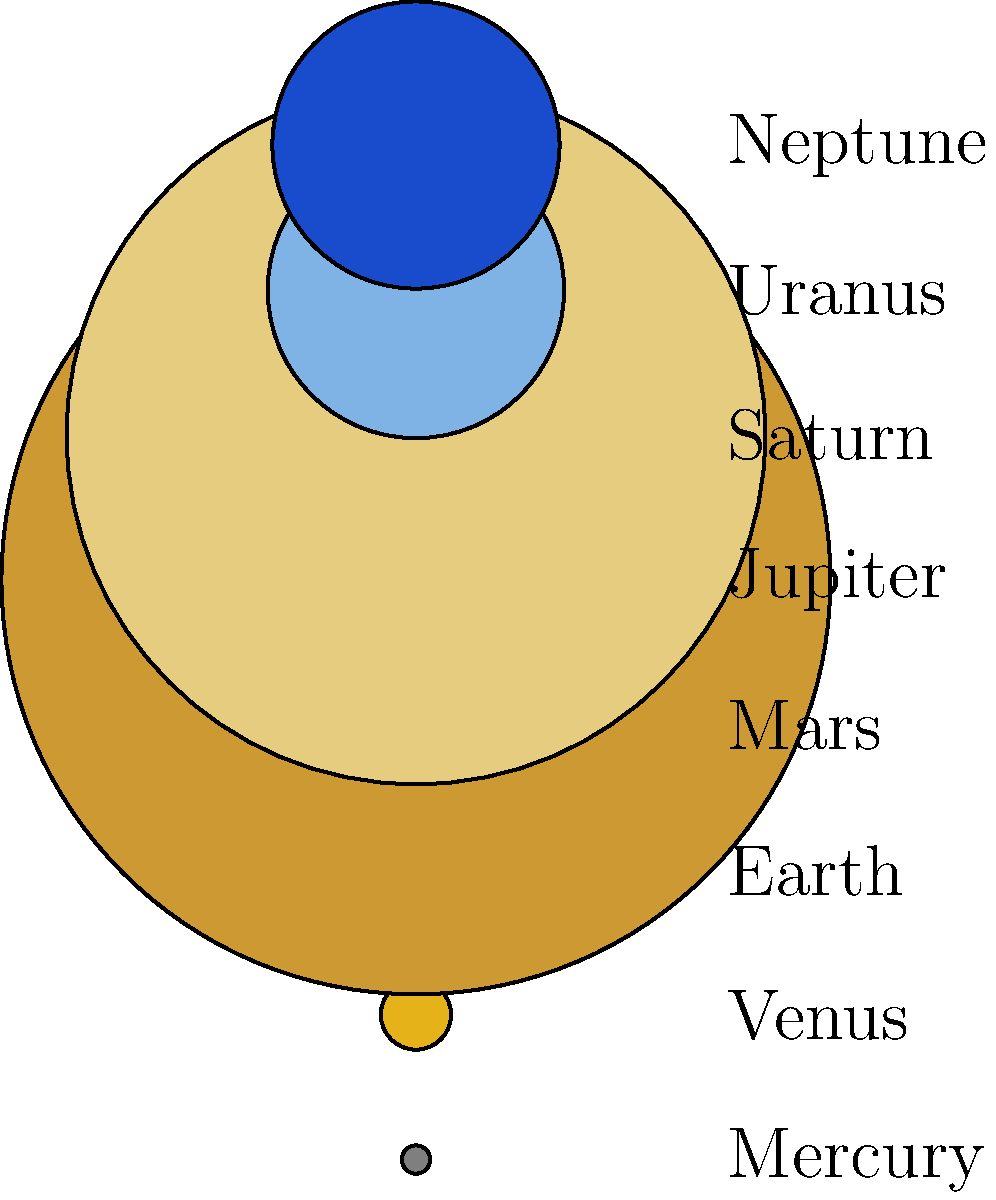In the cosmic jazz ensemble of our solar system, which planet plays the role of the "big bass" with the largest diameter, dwarfing even the smooth rhythm of Earth's blues? To answer this question, let's break down the information presented in the diagram and relate it to our solar system:

1. The diagram shows the relative sizes of the eight planets in our solar system.
2. Each planet is represented by a colored circle, with its name labeled to the right.
3. The sizes of the circles are proportional to the actual diameters of the planets.

Analyzing the diagram:

1. Earth, our home planet, is represented by the blue circle in the third position from the top.
2. We can see that there are two planets significantly larger than Earth and the rest.
3. These two largest planets are Jupiter and Saturn, often referred to as the gas giants.
4. Jupiter, represented by the large orange circle, is visibly larger than Saturn.

Connecting to the jazz theme:

In a jazz ensemble, the bass often provides the foundation and largest sound. Similarly, Jupiter, with its massive size, can be thought of as the "big bass" of our solar system.

Therefore, Jupiter, with its impressive diameter of 142,984 km (the largest in the diagram), stands out as the largest planet in our solar system, truly dwarfing Earth and the other planets.
Answer: Jupiter 